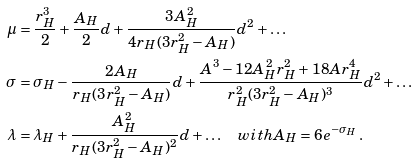Convert formula to latex. <formula><loc_0><loc_0><loc_500><loc_500>\mu & = \frac { r _ { H } ^ { 3 } } { 2 } + \frac { A _ { H } } { 2 } d + \frac { 3 A _ { H } ^ { 2 } } { 4 r _ { H } ( 3 r _ { H } ^ { 2 } - A _ { H } ) } d ^ { 2 } + \dots \\ \sigma & = \sigma _ { H } - \frac { 2 A _ { H } } { r _ { H } ( 3 r _ { H } ^ { 2 } - A _ { H } ) } d + \frac { A ^ { 3 } - 1 2 A _ { H } ^ { 2 } r _ { H } ^ { 2 } + 1 8 A r _ { H } ^ { 4 } } { r _ { H } ^ { 2 } ( 3 r _ { H } ^ { 2 } - A _ { H } ) ^ { 3 } } d ^ { 2 } + \dots \\ \lambda & = \lambda _ { H } + \frac { A _ { H } ^ { 2 } } { r _ { H } ( 3 r _ { H } ^ { 2 } - A _ { H } ) ^ { 2 } } d + \dots \quad w i t h A _ { H } = 6 e ^ { - \sigma _ { H } } \, .</formula> 